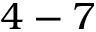<formula> <loc_0><loc_0><loc_500><loc_500>4 - 7</formula> 